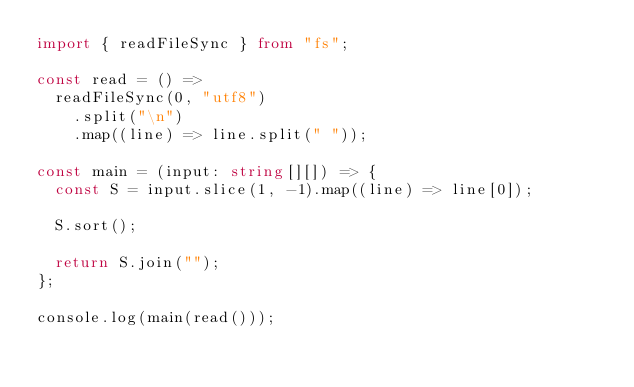<code> <loc_0><loc_0><loc_500><loc_500><_TypeScript_>import { readFileSync } from "fs";

const read = () =>
  readFileSync(0, "utf8")
    .split("\n")
    .map((line) => line.split(" "));

const main = (input: string[][]) => {
  const S = input.slice(1, -1).map((line) => line[0]);

  S.sort();

  return S.join("");
};

console.log(main(read()));
</code> 